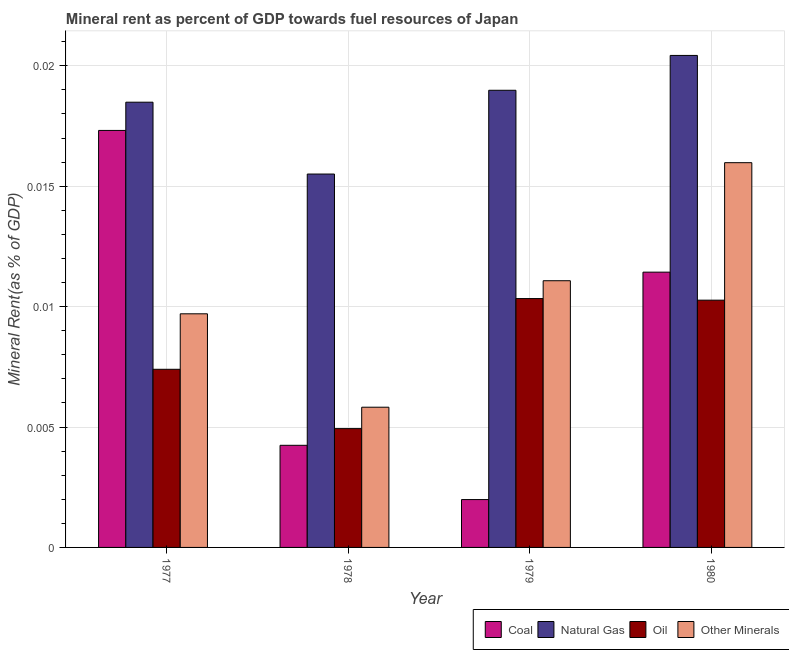Are the number of bars per tick equal to the number of legend labels?
Provide a succinct answer. Yes. Are the number of bars on each tick of the X-axis equal?
Ensure brevity in your answer.  Yes. How many bars are there on the 1st tick from the left?
Make the answer very short. 4. How many bars are there on the 1st tick from the right?
Give a very brief answer. 4. What is the label of the 3rd group of bars from the left?
Keep it short and to the point. 1979. In how many cases, is the number of bars for a given year not equal to the number of legend labels?
Offer a terse response. 0. What is the  rent of other minerals in 1979?
Ensure brevity in your answer.  0.01. Across all years, what is the maximum natural gas rent?
Offer a terse response. 0.02. Across all years, what is the minimum  rent of other minerals?
Make the answer very short. 0.01. In which year was the oil rent maximum?
Keep it short and to the point. 1979. In which year was the coal rent minimum?
Ensure brevity in your answer.  1979. What is the total  rent of other minerals in the graph?
Ensure brevity in your answer.  0.04. What is the difference between the natural gas rent in 1978 and that in 1979?
Offer a terse response. -0. What is the difference between the  rent of other minerals in 1979 and the coal rent in 1980?
Make the answer very short. -0. What is the average  rent of other minerals per year?
Make the answer very short. 0.01. In the year 1980, what is the difference between the natural gas rent and oil rent?
Keep it short and to the point. 0. In how many years, is the natural gas rent greater than 0.017 %?
Provide a succinct answer. 3. What is the ratio of the coal rent in 1977 to that in 1978?
Your answer should be compact. 4.08. What is the difference between the highest and the second highest  rent of other minerals?
Provide a succinct answer. 0. What is the difference between the highest and the lowest oil rent?
Give a very brief answer. 0.01. In how many years, is the natural gas rent greater than the average natural gas rent taken over all years?
Offer a terse response. 3. Is the sum of the  rent of other minerals in 1977 and 1978 greater than the maximum coal rent across all years?
Give a very brief answer. No. Is it the case that in every year, the sum of the coal rent and oil rent is greater than the sum of natural gas rent and  rent of other minerals?
Your answer should be very brief. No. What does the 3rd bar from the left in 1977 represents?
Your answer should be compact. Oil. What does the 3rd bar from the right in 1980 represents?
Keep it short and to the point. Natural Gas. Is it the case that in every year, the sum of the coal rent and natural gas rent is greater than the oil rent?
Your answer should be compact. Yes. How many bars are there?
Make the answer very short. 16. What is the difference between two consecutive major ticks on the Y-axis?
Your answer should be compact. 0.01. Are the values on the major ticks of Y-axis written in scientific E-notation?
Your answer should be compact. No. Does the graph contain grids?
Provide a short and direct response. Yes. How many legend labels are there?
Offer a terse response. 4. How are the legend labels stacked?
Give a very brief answer. Horizontal. What is the title of the graph?
Make the answer very short. Mineral rent as percent of GDP towards fuel resources of Japan. What is the label or title of the X-axis?
Keep it short and to the point. Year. What is the label or title of the Y-axis?
Keep it short and to the point. Mineral Rent(as % of GDP). What is the Mineral Rent(as % of GDP) in Coal in 1977?
Offer a terse response. 0.02. What is the Mineral Rent(as % of GDP) in Natural Gas in 1977?
Offer a terse response. 0.02. What is the Mineral Rent(as % of GDP) of Oil in 1977?
Offer a terse response. 0.01. What is the Mineral Rent(as % of GDP) in Other Minerals in 1977?
Ensure brevity in your answer.  0.01. What is the Mineral Rent(as % of GDP) of Coal in 1978?
Make the answer very short. 0. What is the Mineral Rent(as % of GDP) in Natural Gas in 1978?
Offer a terse response. 0.02. What is the Mineral Rent(as % of GDP) of Oil in 1978?
Ensure brevity in your answer.  0. What is the Mineral Rent(as % of GDP) in Other Minerals in 1978?
Provide a succinct answer. 0.01. What is the Mineral Rent(as % of GDP) in Coal in 1979?
Make the answer very short. 0. What is the Mineral Rent(as % of GDP) in Natural Gas in 1979?
Offer a very short reply. 0.02. What is the Mineral Rent(as % of GDP) in Oil in 1979?
Your answer should be compact. 0.01. What is the Mineral Rent(as % of GDP) of Other Minerals in 1979?
Keep it short and to the point. 0.01. What is the Mineral Rent(as % of GDP) of Coal in 1980?
Keep it short and to the point. 0.01. What is the Mineral Rent(as % of GDP) in Natural Gas in 1980?
Your answer should be compact. 0.02. What is the Mineral Rent(as % of GDP) in Oil in 1980?
Your response must be concise. 0.01. What is the Mineral Rent(as % of GDP) of Other Minerals in 1980?
Your answer should be compact. 0.02. Across all years, what is the maximum Mineral Rent(as % of GDP) in Coal?
Provide a short and direct response. 0.02. Across all years, what is the maximum Mineral Rent(as % of GDP) in Natural Gas?
Your answer should be compact. 0.02. Across all years, what is the maximum Mineral Rent(as % of GDP) of Oil?
Provide a succinct answer. 0.01. Across all years, what is the maximum Mineral Rent(as % of GDP) of Other Minerals?
Your answer should be very brief. 0.02. Across all years, what is the minimum Mineral Rent(as % of GDP) of Coal?
Your answer should be compact. 0. Across all years, what is the minimum Mineral Rent(as % of GDP) of Natural Gas?
Give a very brief answer. 0.02. Across all years, what is the minimum Mineral Rent(as % of GDP) in Oil?
Keep it short and to the point. 0. Across all years, what is the minimum Mineral Rent(as % of GDP) in Other Minerals?
Make the answer very short. 0.01. What is the total Mineral Rent(as % of GDP) of Coal in the graph?
Offer a terse response. 0.04. What is the total Mineral Rent(as % of GDP) in Natural Gas in the graph?
Make the answer very short. 0.07. What is the total Mineral Rent(as % of GDP) of Oil in the graph?
Your answer should be compact. 0.03. What is the total Mineral Rent(as % of GDP) of Other Minerals in the graph?
Provide a succinct answer. 0.04. What is the difference between the Mineral Rent(as % of GDP) of Coal in 1977 and that in 1978?
Your answer should be compact. 0.01. What is the difference between the Mineral Rent(as % of GDP) of Natural Gas in 1977 and that in 1978?
Keep it short and to the point. 0. What is the difference between the Mineral Rent(as % of GDP) in Oil in 1977 and that in 1978?
Provide a succinct answer. 0. What is the difference between the Mineral Rent(as % of GDP) of Other Minerals in 1977 and that in 1978?
Give a very brief answer. 0. What is the difference between the Mineral Rent(as % of GDP) of Coal in 1977 and that in 1979?
Your response must be concise. 0.02. What is the difference between the Mineral Rent(as % of GDP) of Natural Gas in 1977 and that in 1979?
Your answer should be compact. -0. What is the difference between the Mineral Rent(as % of GDP) in Oil in 1977 and that in 1979?
Your answer should be very brief. -0. What is the difference between the Mineral Rent(as % of GDP) in Other Minerals in 1977 and that in 1979?
Your answer should be very brief. -0. What is the difference between the Mineral Rent(as % of GDP) of Coal in 1977 and that in 1980?
Offer a terse response. 0.01. What is the difference between the Mineral Rent(as % of GDP) of Natural Gas in 1977 and that in 1980?
Make the answer very short. -0. What is the difference between the Mineral Rent(as % of GDP) of Oil in 1977 and that in 1980?
Your response must be concise. -0. What is the difference between the Mineral Rent(as % of GDP) in Other Minerals in 1977 and that in 1980?
Give a very brief answer. -0.01. What is the difference between the Mineral Rent(as % of GDP) in Coal in 1978 and that in 1979?
Provide a short and direct response. 0. What is the difference between the Mineral Rent(as % of GDP) in Natural Gas in 1978 and that in 1979?
Provide a short and direct response. -0. What is the difference between the Mineral Rent(as % of GDP) of Oil in 1978 and that in 1979?
Your answer should be very brief. -0.01. What is the difference between the Mineral Rent(as % of GDP) in Other Minerals in 1978 and that in 1979?
Give a very brief answer. -0.01. What is the difference between the Mineral Rent(as % of GDP) in Coal in 1978 and that in 1980?
Offer a very short reply. -0.01. What is the difference between the Mineral Rent(as % of GDP) of Natural Gas in 1978 and that in 1980?
Offer a terse response. -0. What is the difference between the Mineral Rent(as % of GDP) in Oil in 1978 and that in 1980?
Provide a succinct answer. -0.01. What is the difference between the Mineral Rent(as % of GDP) of Other Minerals in 1978 and that in 1980?
Make the answer very short. -0.01. What is the difference between the Mineral Rent(as % of GDP) in Coal in 1979 and that in 1980?
Your answer should be compact. -0.01. What is the difference between the Mineral Rent(as % of GDP) in Natural Gas in 1979 and that in 1980?
Your response must be concise. -0. What is the difference between the Mineral Rent(as % of GDP) in Oil in 1979 and that in 1980?
Your answer should be very brief. 0. What is the difference between the Mineral Rent(as % of GDP) of Other Minerals in 1979 and that in 1980?
Make the answer very short. -0. What is the difference between the Mineral Rent(as % of GDP) in Coal in 1977 and the Mineral Rent(as % of GDP) in Natural Gas in 1978?
Keep it short and to the point. 0. What is the difference between the Mineral Rent(as % of GDP) in Coal in 1977 and the Mineral Rent(as % of GDP) in Oil in 1978?
Ensure brevity in your answer.  0.01. What is the difference between the Mineral Rent(as % of GDP) in Coal in 1977 and the Mineral Rent(as % of GDP) in Other Minerals in 1978?
Make the answer very short. 0.01. What is the difference between the Mineral Rent(as % of GDP) in Natural Gas in 1977 and the Mineral Rent(as % of GDP) in Oil in 1978?
Your answer should be compact. 0.01. What is the difference between the Mineral Rent(as % of GDP) of Natural Gas in 1977 and the Mineral Rent(as % of GDP) of Other Minerals in 1978?
Your answer should be very brief. 0.01. What is the difference between the Mineral Rent(as % of GDP) of Oil in 1977 and the Mineral Rent(as % of GDP) of Other Minerals in 1978?
Offer a very short reply. 0. What is the difference between the Mineral Rent(as % of GDP) of Coal in 1977 and the Mineral Rent(as % of GDP) of Natural Gas in 1979?
Keep it short and to the point. -0. What is the difference between the Mineral Rent(as % of GDP) of Coal in 1977 and the Mineral Rent(as % of GDP) of Oil in 1979?
Your response must be concise. 0.01. What is the difference between the Mineral Rent(as % of GDP) of Coal in 1977 and the Mineral Rent(as % of GDP) of Other Minerals in 1979?
Provide a short and direct response. 0.01. What is the difference between the Mineral Rent(as % of GDP) of Natural Gas in 1977 and the Mineral Rent(as % of GDP) of Oil in 1979?
Offer a very short reply. 0.01. What is the difference between the Mineral Rent(as % of GDP) in Natural Gas in 1977 and the Mineral Rent(as % of GDP) in Other Minerals in 1979?
Make the answer very short. 0.01. What is the difference between the Mineral Rent(as % of GDP) in Oil in 1977 and the Mineral Rent(as % of GDP) in Other Minerals in 1979?
Your response must be concise. -0. What is the difference between the Mineral Rent(as % of GDP) of Coal in 1977 and the Mineral Rent(as % of GDP) of Natural Gas in 1980?
Make the answer very short. -0. What is the difference between the Mineral Rent(as % of GDP) in Coal in 1977 and the Mineral Rent(as % of GDP) in Oil in 1980?
Provide a succinct answer. 0.01. What is the difference between the Mineral Rent(as % of GDP) in Coal in 1977 and the Mineral Rent(as % of GDP) in Other Minerals in 1980?
Your response must be concise. 0. What is the difference between the Mineral Rent(as % of GDP) in Natural Gas in 1977 and the Mineral Rent(as % of GDP) in Oil in 1980?
Ensure brevity in your answer.  0.01. What is the difference between the Mineral Rent(as % of GDP) in Natural Gas in 1977 and the Mineral Rent(as % of GDP) in Other Minerals in 1980?
Ensure brevity in your answer.  0. What is the difference between the Mineral Rent(as % of GDP) of Oil in 1977 and the Mineral Rent(as % of GDP) of Other Minerals in 1980?
Offer a terse response. -0.01. What is the difference between the Mineral Rent(as % of GDP) of Coal in 1978 and the Mineral Rent(as % of GDP) of Natural Gas in 1979?
Your response must be concise. -0.01. What is the difference between the Mineral Rent(as % of GDP) in Coal in 1978 and the Mineral Rent(as % of GDP) in Oil in 1979?
Ensure brevity in your answer.  -0.01. What is the difference between the Mineral Rent(as % of GDP) of Coal in 1978 and the Mineral Rent(as % of GDP) of Other Minerals in 1979?
Provide a short and direct response. -0.01. What is the difference between the Mineral Rent(as % of GDP) of Natural Gas in 1978 and the Mineral Rent(as % of GDP) of Oil in 1979?
Provide a succinct answer. 0.01. What is the difference between the Mineral Rent(as % of GDP) of Natural Gas in 1978 and the Mineral Rent(as % of GDP) of Other Minerals in 1979?
Your response must be concise. 0. What is the difference between the Mineral Rent(as % of GDP) of Oil in 1978 and the Mineral Rent(as % of GDP) of Other Minerals in 1979?
Your answer should be compact. -0.01. What is the difference between the Mineral Rent(as % of GDP) in Coal in 1978 and the Mineral Rent(as % of GDP) in Natural Gas in 1980?
Provide a succinct answer. -0.02. What is the difference between the Mineral Rent(as % of GDP) in Coal in 1978 and the Mineral Rent(as % of GDP) in Oil in 1980?
Provide a succinct answer. -0.01. What is the difference between the Mineral Rent(as % of GDP) in Coal in 1978 and the Mineral Rent(as % of GDP) in Other Minerals in 1980?
Offer a very short reply. -0.01. What is the difference between the Mineral Rent(as % of GDP) of Natural Gas in 1978 and the Mineral Rent(as % of GDP) of Oil in 1980?
Give a very brief answer. 0.01. What is the difference between the Mineral Rent(as % of GDP) in Natural Gas in 1978 and the Mineral Rent(as % of GDP) in Other Minerals in 1980?
Provide a succinct answer. -0. What is the difference between the Mineral Rent(as % of GDP) of Oil in 1978 and the Mineral Rent(as % of GDP) of Other Minerals in 1980?
Offer a very short reply. -0.01. What is the difference between the Mineral Rent(as % of GDP) in Coal in 1979 and the Mineral Rent(as % of GDP) in Natural Gas in 1980?
Your response must be concise. -0.02. What is the difference between the Mineral Rent(as % of GDP) of Coal in 1979 and the Mineral Rent(as % of GDP) of Oil in 1980?
Offer a very short reply. -0.01. What is the difference between the Mineral Rent(as % of GDP) of Coal in 1979 and the Mineral Rent(as % of GDP) of Other Minerals in 1980?
Offer a very short reply. -0.01. What is the difference between the Mineral Rent(as % of GDP) in Natural Gas in 1979 and the Mineral Rent(as % of GDP) in Oil in 1980?
Give a very brief answer. 0.01. What is the difference between the Mineral Rent(as % of GDP) of Natural Gas in 1979 and the Mineral Rent(as % of GDP) of Other Minerals in 1980?
Ensure brevity in your answer.  0. What is the difference between the Mineral Rent(as % of GDP) in Oil in 1979 and the Mineral Rent(as % of GDP) in Other Minerals in 1980?
Your answer should be very brief. -0.01. What is the average Mineral Rent(as % of GDP) of Coal per year?
Ensure brevity in your answer.  0.01. What is the average Mineral Rent(as % of GDP) in Natural Gas per year?
Offer a very short reply. 0.02. What is the average Mineral Rent(as % of GDP) in Oil per year?
Provide a short and direct response. 0.01. What is the average Mineral Rent(as % of GDP) in Other Minerals per year?
Give a very brief answer. 0.01. In the year 1977, what is the difference between the Mineral Rent(as % of GDP) of Coal and Mineral Rent(as % of GDP) of Natural Gas?
Offer a terse response. -0. In the year 1977, what is the difference between the Mineral Rent(as % of GDP) in Coal and Mineral Rent(as % of GDP) in Oil?
Provide a short and direct response. 0.01. In the year 1977, what is the difference between the Mineral Rent(as % of GDP) in Coal and Mineral Rent(as % of GDP) in Other Minerals?
Your response must be concise. 0.01. In the year 1977, what is the difference between the Mineral Rent(as % of GDP) of Natural Gas and Mineral Rent(as % of GDP) of Oil?
Your response must be concise. 0.01. In the year 1977, what is the difference between the Mineral Rent(as % of GDP) in Natural Gas and Mineral Rent(as % of GDP) in Other Minerals?
Your answer should be very brief. 0.01. In the year 1977, what is the difference between the Mineral Rent(as % of GDP) in Oil and Mineral Rent(as % of GDP) in Other Minerals?
Offer a very short reply. -0. In the year 1978, what is the difference between the Mineral Rent(as % of GDP) in Coal and Mineral Rent(as % of GDP) in Natural Gas?
Offer a very short reply. -0.01. In the year 1978, what is the difference between the Mineral Rent(as % of GDP) in Coal and Mineral Rent(as % of GDP) in Oil?
Provide a short and direct response. -0. In the year 1978, what is the difference between the Mineral Rent(as % of GDP) in Coal and Mineral Rent(as % of GDP) in Other Minerals?
Offer a terse response. -0. In the year 1978, what is the difference between the Mineral Rent(as % of GDP) in Natural Gas and Mineral Rent(as % of GDP) in Oil?
Your answer should be very brief. 0.01. In the year 1978, what is the difference between the Mineral Rent(as % of GDP) in Natural Gas and Mineral Rent(as % of GDP) in Other Minerals?
Your answer should be compact. 0.01. In the year 1978, what is the difference between the Mineral Rent(as % of GDP) of Oil and Mineral Rent(as % of GDP) of Other Minerals?
Keep it short and to the point. -0. In the year 1979, what is the difference between the Mineral Rent(as % of GDP) in Coal and Mineral Rent(as % of GDP) in Natural Gas?
Your response must be concise. -0.02. In the year 1979, what is the difference between the Mineral Rent(as % of GDP) of Coal and Mineral Rent(as % of GDP) of Oil?
Offer a very short reply. -0.01. In the year 1979, what is the difference between the Mineral Rent(as % of GDP) of Coal and Mineral Rent(as % of GDP) of Other Minerals?
Offer a terse response. -0.01. In the year 1979, what is the difference between the Mineral Rent(as % of GDP) of Natural Gas and Mineral Rent(as % of GDP) of Oil?
Ensure brevity in your answer.  0.01. In the year 1979, what is the difference between the Mineral Rent(as % of GDP) of Natural Gas and Mineral Rent(as % of GDP) of Other Minerals?
Keep it short and to the point. 0.01. In the year 1979, what is the difference between the Mineral Rent(as % of GDP) in Oil and Mineral Rent(as % of GDP) in Other Minerals?
Your answer should be compact. -0. In the year 1980, what is the difference between the Mineral Rent(as % of GDP) in Coal and Mineral Rent(as % of GDP) in Natural Gas?
Make the answer very short. -0.01. In the year 1980, what is the difference between the Mineral Rent(as % of GDP) in Coal and Mineral Rent(as % of GDP) in Oil?
Offer a very short reply. 0. In the year 1980, what is the difference between the Mineral Rent(as % of GDP) of Coal and Mineral Rent(as % of GDP) of Other Minerals?
Keep it short and to the point. -0. In the year 1980, what is the difference between the Mineral Rent(as % of GDP) of Natural Gas and Mineral Rent(as % of GDP) of Oil?
Ensure brevity in your answer.  0.01. In the year 1980, what is the difference between the Mineral Rent(as % of GDP) in Natural Gas and Mineral Rent(as % of GDP) in Other Minerals?
Ensure brevity in your answer.  0. In the year 1980, what is the difference between the Mineral Rent(as % of GDP) in Oil and Mineral Rent(as % of GDP) in Other Minerals?
Give a very brief answer. -0.01. What is the ratio of the Mineral Rent(as % of GDP) in Coal in 1977 to that in 1978?
Provide a succinct answer. 4.08. What is the ratio of the Mineral Rent(as % of GDP) of Natural Gas in 1977 to that in 1978?
Your answer should be very brief. 1.19. What is the ratio of the Mineral Rent(as % of GDP) of Oil in 1977 to that in 1978?
Provide a succinct answer. 1.5. What is the ratio of the Mineral Rent(as % of GDP) in Other Minerals in 1977 to that in 1978?
Ensure brevity in your answer.  1.67. What is the ratio of the Mineral Rent(as % of GDP) of Coal in 1977 to that in 1979?
Make the answer very short. 8.71. What is the ratio of the Mineral Rent(as % of GDP) of Natural Gas in 1977 to that in 1979?
Your response must be concise. 0.97. What is the ratio of the Mineral Rent(as % of GDP) of Oil in 1977 to that in 1979?
Keep it short and to the point. 0.72. What is the ratio of the Mineral Rent(as % of GDP) in Other Minerals in 1977 to that in 1979?
Your response must be concise. 0.88. What is the ratio of the Mineral Rent(as % of GDP) in Coal in 1977 to that in 1980?
Provide a succinct answer. 1.51. What is the ratio of the Mineral Rent(as % of GDP) of Natural Gas in 1977 to that in 1980?
Make the answer very short. 0.9. What is the ratio of the Mineral Rent(as % of GDP) in Oil in 1977 to that in 1980?
Ensure brevity in your answer.  0.72. What is the ratio of the Mineral Rent(as % of GDP) of Other Minerals in 1977 to that in 1980?
Make the answer very short. 0.61. What is the ratio of the Mineral Rent(as % of GDP) in Coal in 1978 to that in 1979?
Ensure brevity in your answer.  2.13. What is the ratio of the Mineral Rent(as % of GDP) in Natural Gas in 1978 to that in 1979?
Give a very brief answer. 0.82. What is the ratio of the Mineral Rent(as % of GDP) in Oil in 1978 to that in 1979?
Keep it short and to the point. 0.48. What is the ratio of the Mineral Rent(as % of GDP) in Other Minerals in 1978 to that in 1979?
Your response must be concise. 0.53. What is the ratio of the Mineral Rent(as % of GDP) of Coal in 1978 to that in 1980?
Give a very brief answer. 0.37. What is the ratio of the Mineral Rent(as % of GDP) of Natural Gas in 1978 to that in 1980?
Your answer should be very brief. 0.76. What is the ratio of the Mineral Rent(as % of GDP) in Oil in 1978 to that in 1980?
Your response must be concise. 0.48. What is the ratio of the Mineral Rent(as % of GDP) of Other Minerals in 1978 to that in 1980?
Give a very brief answer. 0.36. What is the ratio of the Mineral Rent(as % of GDP) in Coal in 1979 to that in 1980?
Keep it short and to the point. 0.17. What is the ratio of the Mineral Rent(as % of GDP) of Natural Gas in 1979 to that in 1980?
Ensure brevity in your answer.  0.93. What is the ratio of the Mineral Rent(as % of GDP) in Other Minerals in 1979 to that in 1980?
Ensure brevity in your answer.  0.69. What is the difference between the highest and the second highest Mineral Rent(as % of GDP) of Coal?
Provide a succinct answer. 0.01. What is the difference between the highest and the second highest Mineral Rent(as % of GDP) of Natural Gas?
Your response must be concise. 0. What is the difference between the highest and the second highest Mineral Rent(as % of GDP) of Oil?
Offer a terse response. 0. What is the difference between the highest and the second highest Mineral Rent(as % of GDP) in Other Minerals?
Your answer should be compact. 0. What is the difference between the highest and the lowest Mineral Rent(as % of GDP) of Coal?
Keep it short and to the point. 0.02. What is the difference between the highest and the lowest Mineral Rent(as % of GDP) of Natural Gas?
Your response must be concise. 0. What is the difference between the highest and the lowest Mineral Rent(as % of GDP) of Oil?
Give a very brief answer. 0.01. What is the difference between the highest and the lowest Mineral Rent(as % of GDP) in Other Minerals?
Keep it short and to the point. 0.01. 